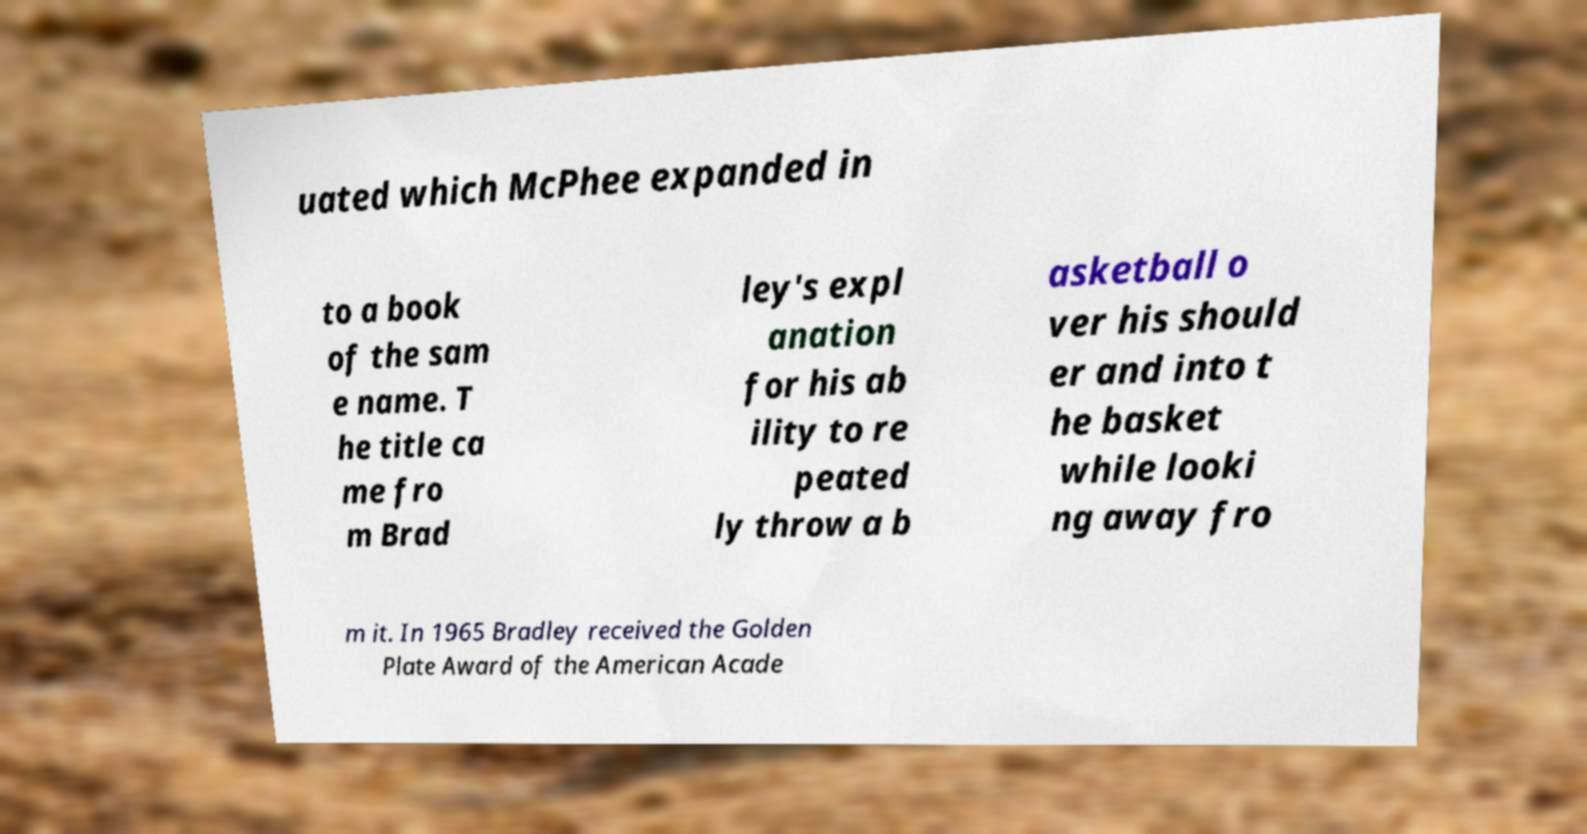For documentation purposes, I need the text within this image transcribed. Could you provide that? uated which McPhee expanded in to a book of the sam e name. T he title ca me fro m Brad ley's expl anation for his ab ility to re peated ly throw a b asketball o ver his should er and into t he basket while looki ng away fro m it. In 1965 Bradley received the Golden Plate Award of the American Acade 